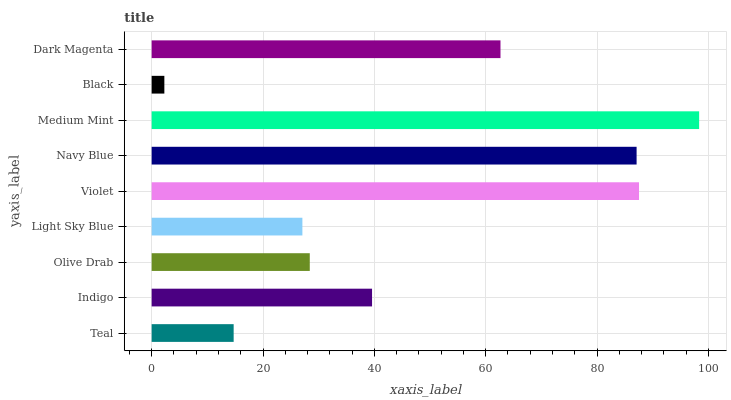Is Black the minimum?
Answer yes or no. Yes. Is Medium Mint the maximum?
Answer yes or no. Yes. Is Indigo the minimum?
Answer yes or no. No. Is Indigo the maximum?
Answer yes or no. No. Is Indigo greater than Teal?
Answer yes or no. Yes. Is Teal less than Indigo?
Answer yes or no. Yes. Is Teal greater than Indigo?
Answer yes or no. No. Is Indigo less than Teal?
Answer yes or no. No. Is Indigo the high median?
Answer yes or no. Yes. Is Indigo the low median?
Answer yes or no. Yes. Is Violet the high median?
Answer yes or no. No. Is Black the low median?
Answer yes or no. No. 